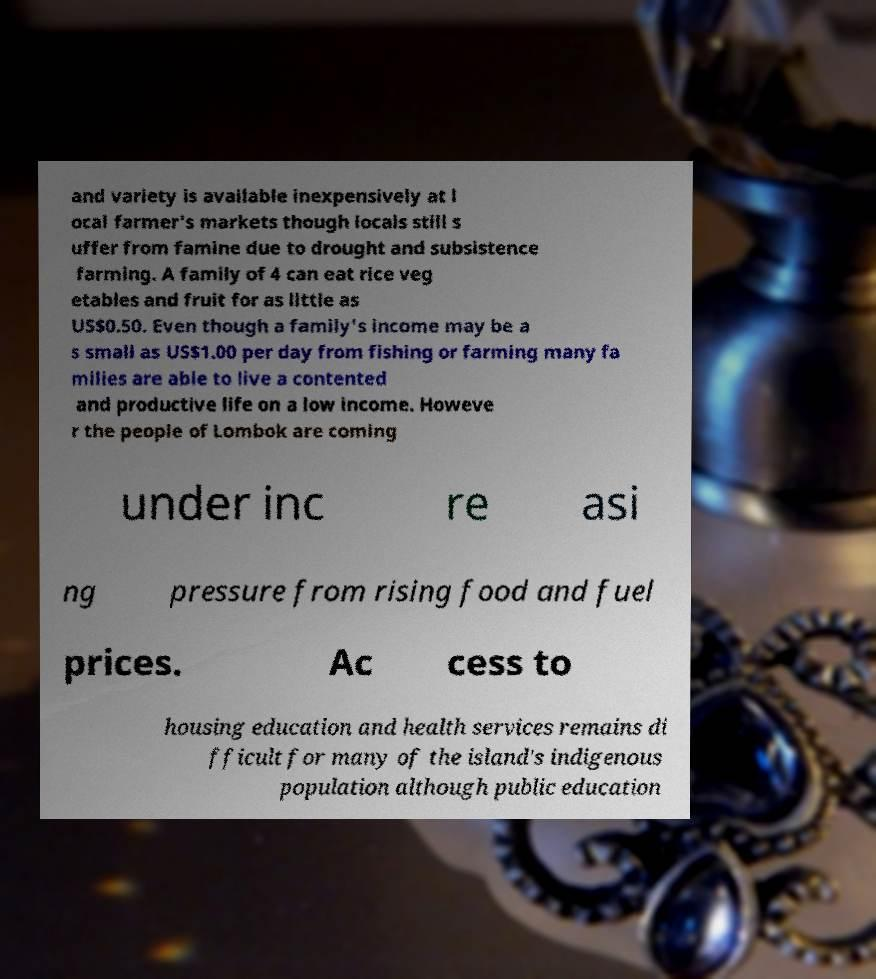There's text embedded in this image that I need extracted. Can you transcribe it verbatim? and variety is available inexpensively at l ocal farmer's markets though locals still s uffer from famine due to drought and subsistence farming. A family of 4 can eat rice veg etables and fruit for as little as US$0.50. Even though a family's income may be a s small as US$1.00 per day from fishing or farming many fa milies are able to live a contented and productive life on a low income. Howeve r the people of Lombok are coming under inc re asi ng pressure from rising food and fuel prices. Ac cess to housing education and health services remains di fficult for many of the island's indigenous population although public education 